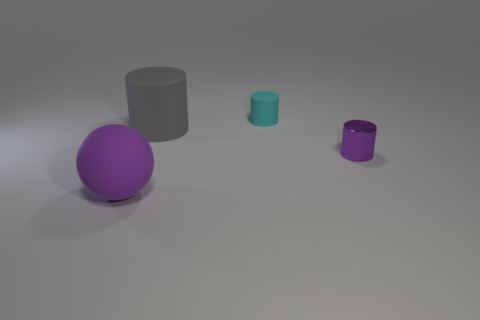Is there a thing that has the same size as the cyan rubber cylinder?
Your answer should be compact. Yes. What material is the purple object behind the big purple matte thing?
Your answer should be very brief. Metal. Does the large thing that is on the right side of the ball have the same material as the small cyan thing?
Offer a very short reply. Yes. Is there a gray thing?
Your answer should be very brief. Yes. What color is the tiny cylinder that is the same material as the gray thing?
Your answer should be very brief. Cyan. What is the color of the big thing right of the purple object that is left of the tiny object that is to the right of the tiny matte thing?
Keep it short and to the point. Gray. There is a matte ball; is it the same size as the purple thing that is behind the large purple matte object?
Your answer should be very brief. No. How many things are either purple things that are on the left side of the tiny cyan object or tiny cylinders that are behind the small purple object?
Provide a succinct answer. 2. There is another object that is the same size as the gray rubber object; what shape is it?
Ensure brevity in your answer.  Sphere. The big matte object behind the thing that is right of the tiny cylinder that is to the left of the tiny purple metallic cylinder is what shape?
Offer a very short reply. Cylinder. 